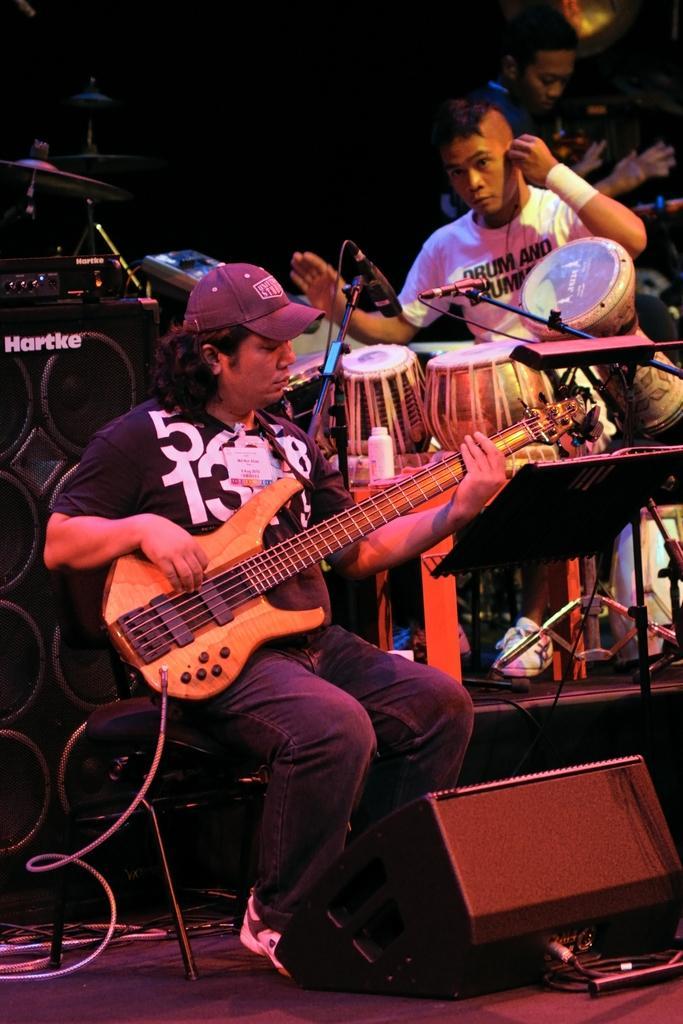In one or two sentences, can you explain what this image depicts? 3 people are present. the person at the front is playing guitar. the person at the center is playing drums. the person at the back is standing. there are speakers at the left. 